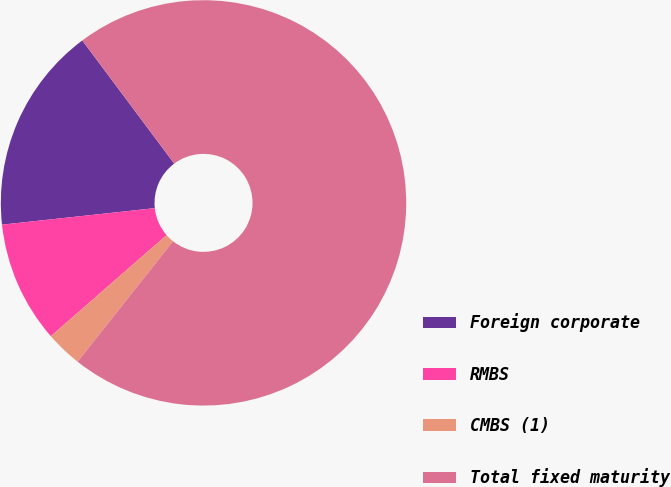Convert chart to OTSL. <chart><loc_0><loc_0><loc_500><loc_500><pie_chart><fcel>Foreign corporate<fcel>RMBS<fcel>CMBS (1)<fcel>Total fixed maturity<nl><fcel>16.51%<fcel>9.71%<fcel>2.91%<fcel>70.87%<nl></chart> 